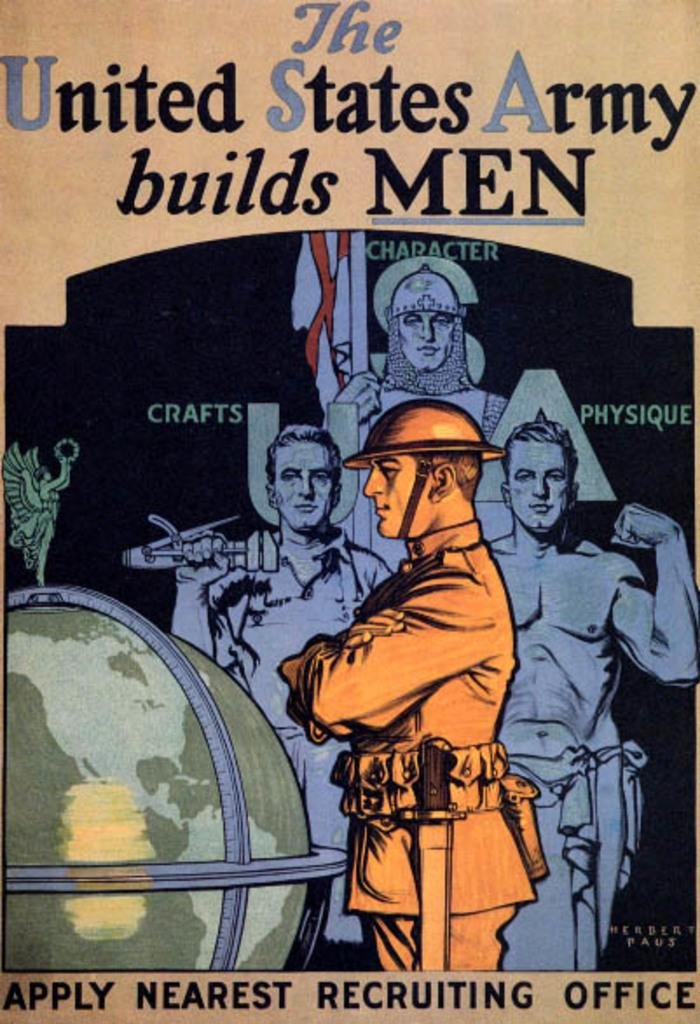What is the main subject of the image? The main subject of the image is a cover of a book. What else can be seen in the image besides the book cover? There are persons in the center of the image and a globe on the left side of the image. Is there any text present in the image? Yes, there is text is present at the top and bottom of the image. What type of lake can be seen in the image? There is no lake present in the image. Can you describe the scarecrow in the image? There is no scarecrow present in the image. 